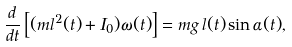<formula> <loc_0><loc_0><loc_500><loc_500>\frac { d } { d t } \left [ ( m l ^ { 2 } ( t ) + I _ { 0 } ) \omega ( t ) \right ] = m g \, l ( t ) \sin \alpha ( t ) ,</formula> 